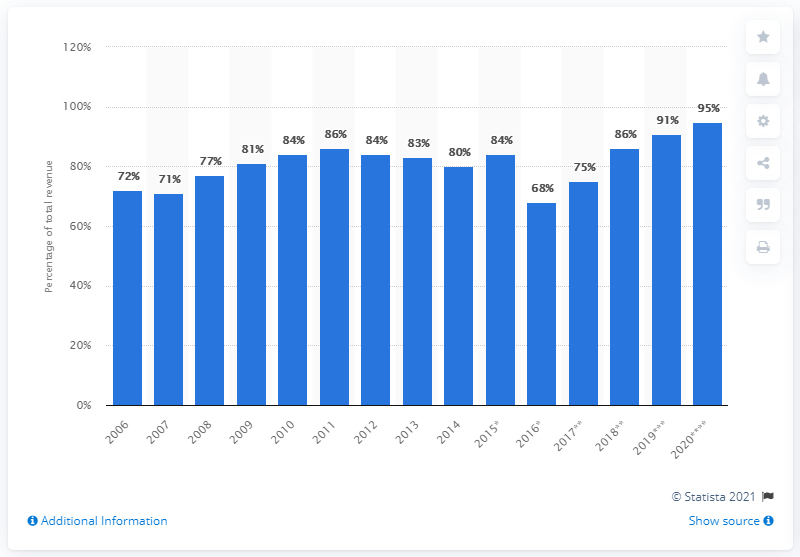Identify some key points in this picture. In 2020, approximately 95% of Bristol-Myers Squibb's total revenue was contributed by the 13 prioritized key products. 